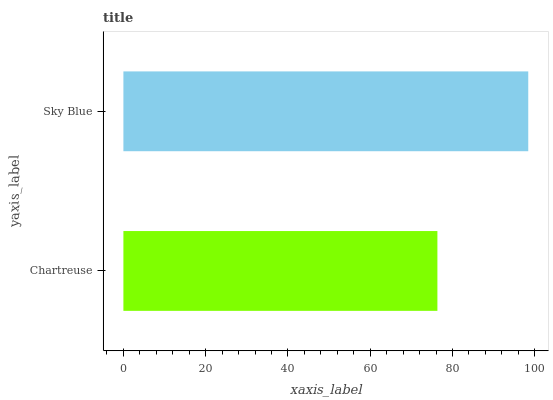Is Chartreuse the minimum?
Answer yes or no. Yes. Is Sky Blue the maximum?
Answer yes or no. Yes. Is Sky Blue the minimum?
Answer yes or no. No. Is Sky Blue greater than Chartreuse?
Answer yes or no. Yes. Is Chartreuse less than Sky Blue?
Answer yes or no. Yes. Is Chartreuse greater than Sky Blue?
Answer yes or no. No. Is Sky Blue less than Chartreuse?
Answer yes or no. No. Is Sky Blue the high median?
Answer yes or no. Yes. Is Chartreuse the low median?
Answer yes or no. Yes. Is Chartreuse the high median?
Answer yes or no. No. Is Sky Blue the low median?
Answer yes or no. No. 